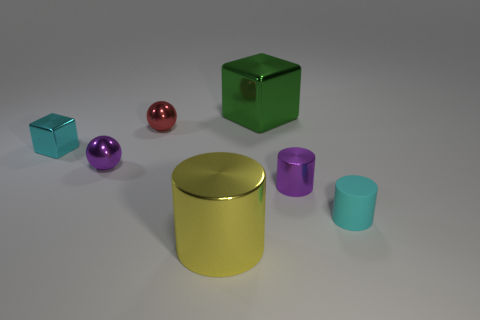The big metallic thing behind the small cylinder that is in front of the small shiny thing that is right of the large yellow shiny cylinder is what color?
Your answer should be compact. Green. There is a purple cylinder that is the same size as the matte thing; what is its material?
Your answer should be compact. Metal. How many purple spheres have the same material as the large block?
Your response must be concise. 1. Is the size of the purple shiny thing in front of the tiny purple metal sphere the same as the block that is to the right of the large yellow shiny cylinder?
Keep it short and to the point. No. The shiny cube in front of the small red thing is what color?
Make the answer very short. Cyan. What material is the small cylinder that is the same color as the small shiny block?
Your answer should be compact. Rubber. What number of large metal cylinders are the same color as the rubber cylinder?
Your answer should be compact. 0. There is a yellow metallic object; does it have the same size as the cyan object behind the small rubber thing?
Ensure brevity in your answer.  No. What size is the ball behind the tiny metal cube that is on the left side of the large object that is in front of the big shiny block?
Make the answer very short. Small. What number of cyan cylinders are in front of the purple cylinder?
Your response must be concise. 1. 